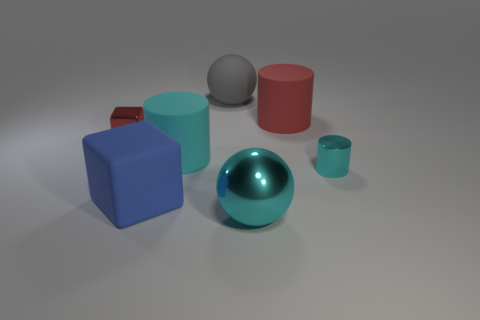What materials do these objects look like they're made of based on their appearance? From the image, the objects appear to be made of different materials. The large gray sphere and the red cube have a matte finish, suggesting a non-metallic surface. The large blue sphere has a reflective surface, indicating it could be metallic. The blue cube, teal cylinder, and small cup have a less reflective, more diffuse surface, which could suggest a plastic or ceramic material. 